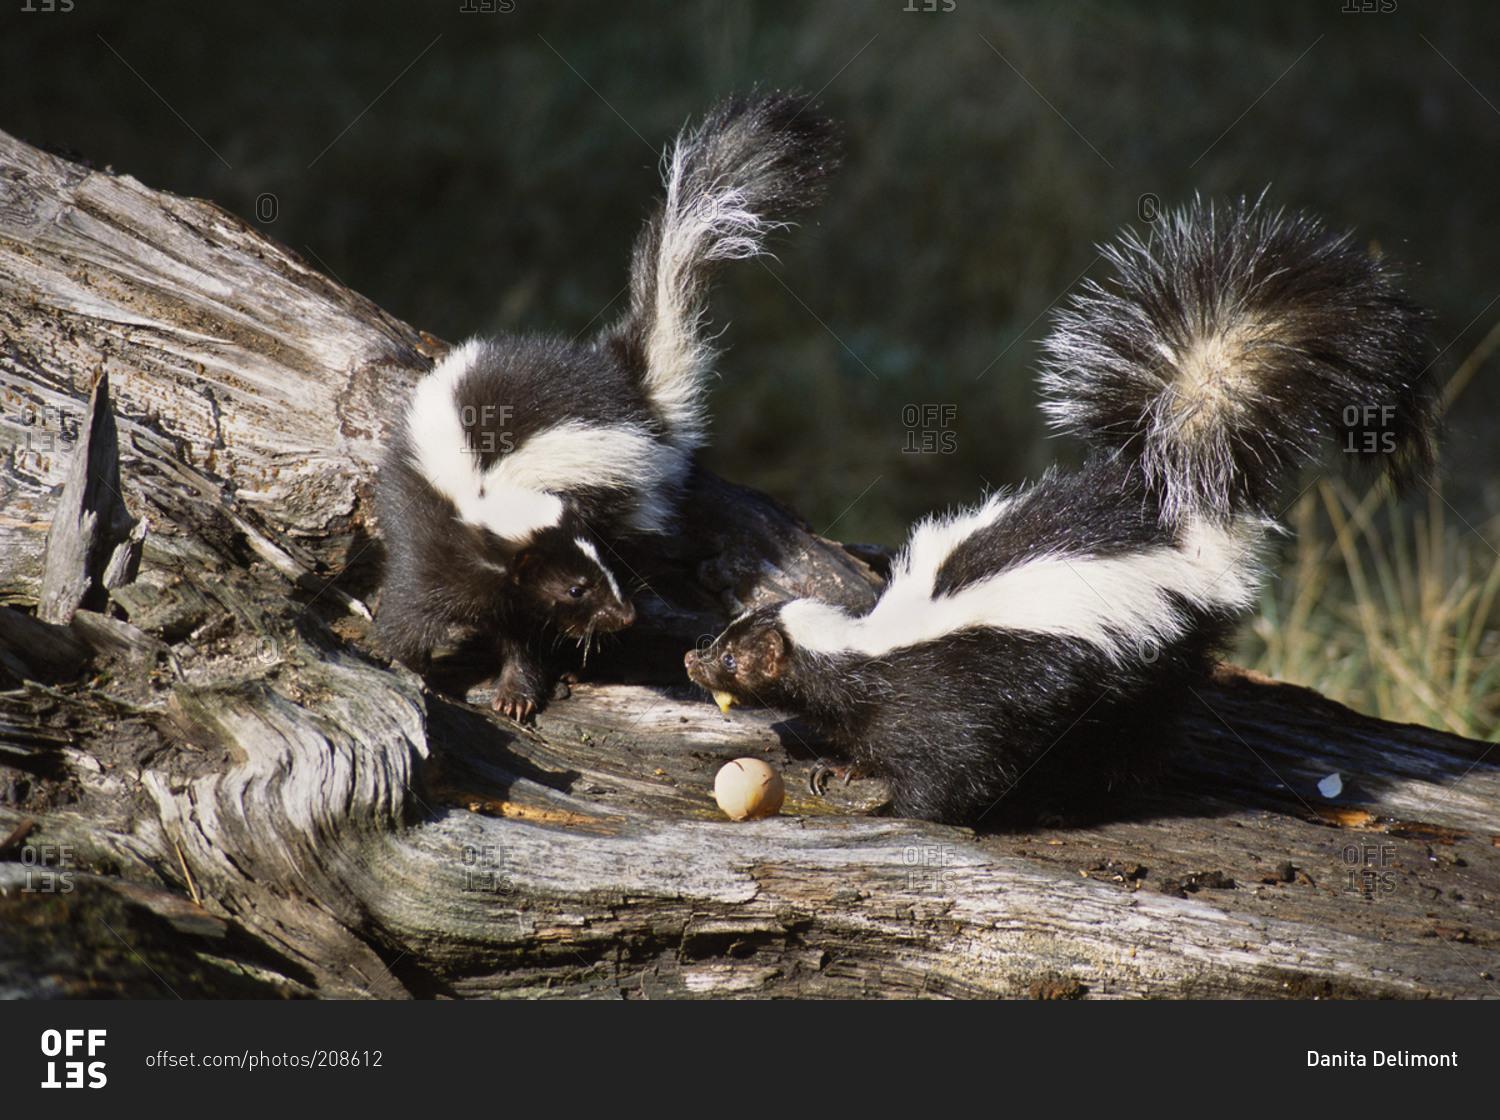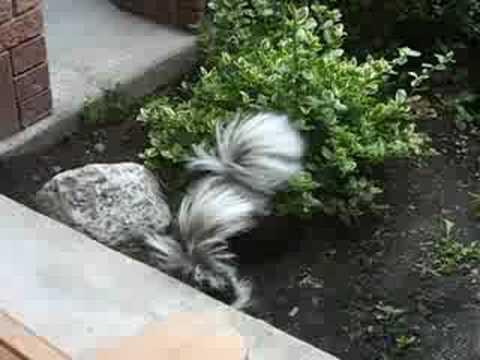The first image is the image on the left, the second image is the image on the right. Given the left and right images, does the statement "Three or fewer mammals are visible." hold true? Answer yes or no. Yes. The first image is the image on the left, the second image is the image on the right. For the images shown, is this caption "The combined images contain at least four skunks, including two side-by side with their faces pointing toward each other." true? Answer yes or no. Yes. 